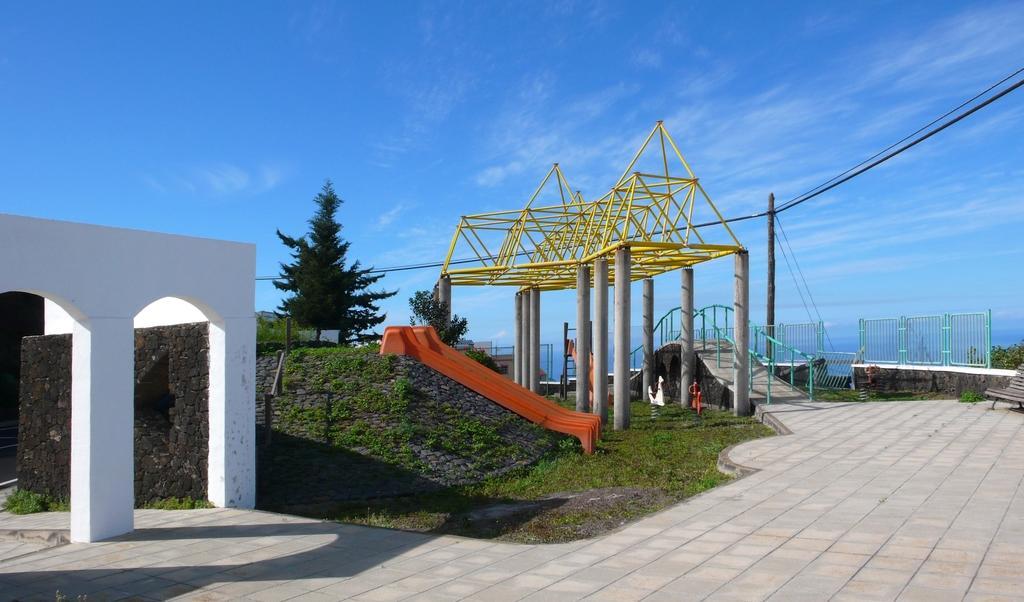In one or two sentences, can you explain what this image depicts? In this image there is a slide in the middle. Beside the slide there are pillars on which there is an architecture made of rods. On the right side there is a wall on which is a fence. In the middle there is a pole to which there are wires. At the top there is the sky. On the left side there is an arch like structure. On the ground there is grass. 